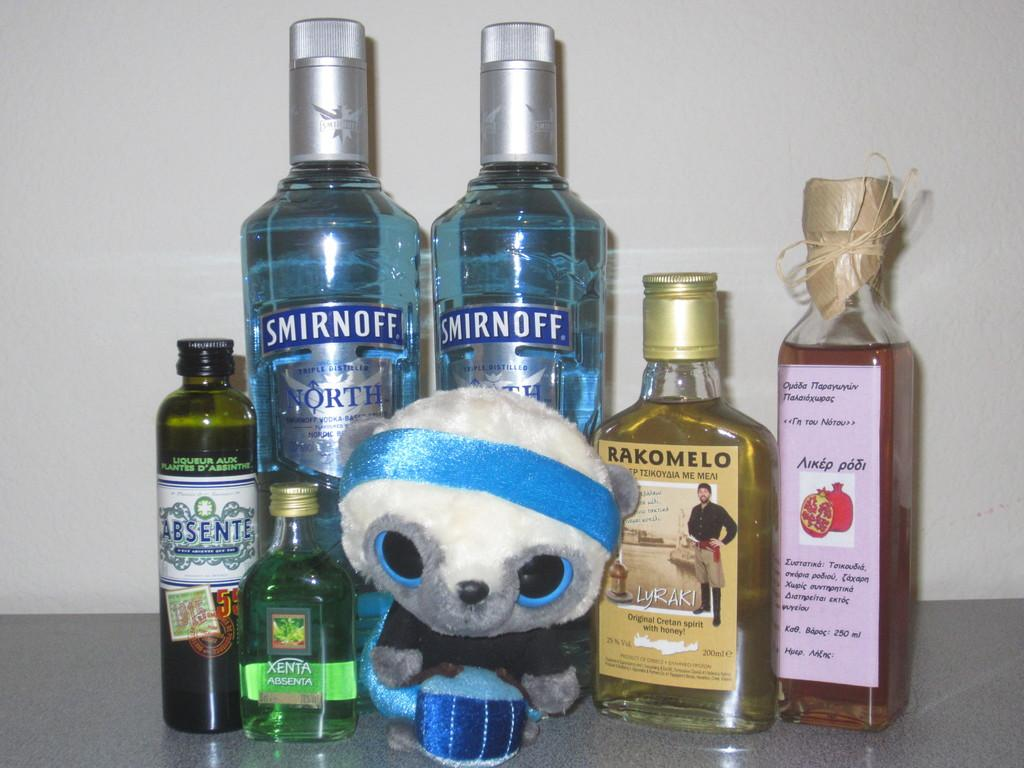What type of beverages are present in the image? There is a bunch of bottles of wine in the image. What other object can be seen in the image besides the bottles of wine? There is a toy in the image. What type of music can be heard coming from the toy in the image? There is no indication in the image that the toy is making any sounds, let alone music. 